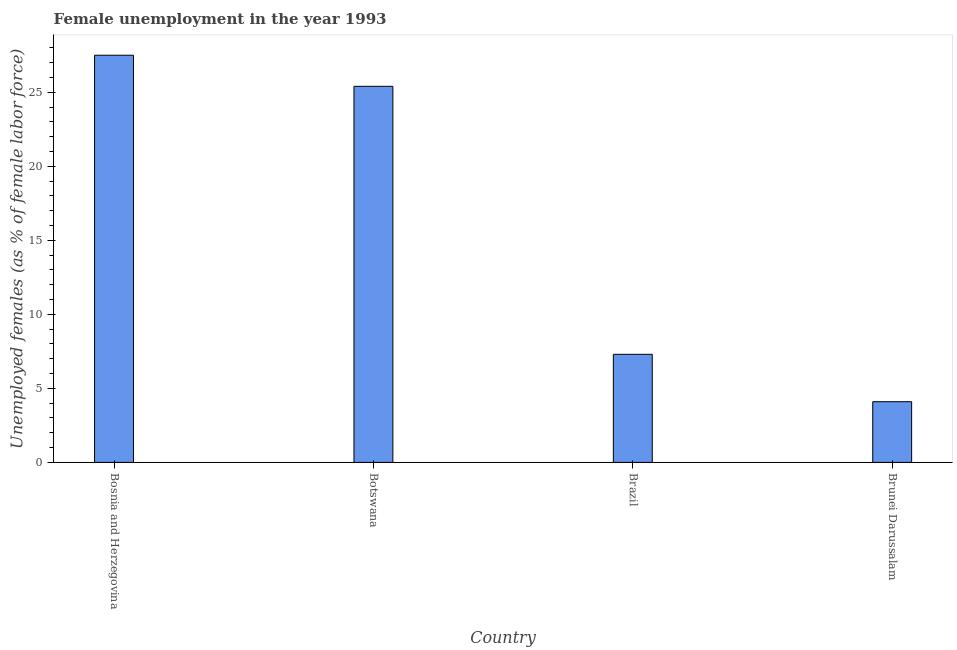Does the graph contain any zero values?
Ensure brevity in your answer.  No. Does the graph contain grids?
Your answer should be compact. No. What is the title of the graph?
Provide a short and direct response. Female unemployment in the year 1993. What is the label or title of the X-axis?
Your answer should be compact. Country. What is the label or title of the Y-axis?
Keep it short and to the point. Unemployed females (as % of female labor force). What is the unemployed females population in Botswana?
Make the answer very short. 25.4. Across all countries, what is the minimum unemployed females population?
Keep it short and to the point. 4.1. In which country was the unemployed females population maximum?
Provide a short and direct response. Bosnia and Herzegovina. In which country was the unemployed females population minimum?
Offer a terse response. Brunei Darussalam. What is the sum of the unemployed females population?
Provide a succinct answer. 64.3. What is the difference between the unemployed females population in Brazil and Brunei Darussalam?
Keep it short and to the point. 3.2. What is the average unemployed females population per country?
Offer a terse response. 16.07. What is the median unemployed females population?
Offer a terse response. 16.35. In how many countries, is the unemployed females population greater than 12 %?
Ensure brevity in your answer.  2. What is the ratio of the unemployed females population in Bosnia and Herzegovina to that in Brazil?
Offer a terse response. 3.77. Is the difference between the unemployed females population in Botswana and Brazil greater than the difference between any two countries?
Give a very brief answer. No. What is the difference between the highest and the lowest unemployed females population?
Ensure brevity in your answer.  23.4. In how many countries, is the unemployed females population greater than the average unemployed females population taken over all countries?
Provide a succinct answer. 2. How many bars are there?
Ensure brevity in your answer.  4. Are all the bars in the graph horizontal?
Offer a very short reply. No. How many countries are there in the graph?
Keep it short and to the point. 4. What is the difference between two consecutive major ticks on the Y-axis?
Your answer should be very brief. 5. Are the values on the major ticks of Y-axis written in scientific E-notation?
Give a very brief answer. No. What is the Unemployed females (as % of female labor force) in Botswana?
Give a very brief answer. 25.4. What is the Unemployed females (as % of female labor force) of Brazil?
Give a very brief answer. 7.3. What is the Unemployed females (as % of female labor force) in Brunei Darussalam?
Ensure brevity in your answer.  4.1. What is the difference between the Unemployed females (as % of female labor force) in Bosnia and Herzegovina and Brazil?
Make the answer very short. 20.2. What is the difference between the Unemployed females (as % of female labor force) in Bosnia and Herzegovina and Brunei Darussalam?
Provide a short and direct response. 23.4. What is the difference between the Unemployed females (as % of female labor force) in Botswana and Brazil?
Your response must be concise. 18.1. What is the difference between the Unemployed females (as % of female labor force) in Botswana and Brunei Darussalam?
Your answer should be very brief. 21.3. What is the difference between the Unemployed females (as % of female labor force) in Brazil and Brunei Darussalam?
Make the answer very short. 3.2. What is the ratio of the Unemployed females (as % of female labor force) in Bosnia and Herzegovina to that in Botswana?
Your answer should be very brief. 1.08. What is the ratio of the Unemployed females (as % of female labor force) in Bosnia and Herzegovina to that in Brazil?
Provide a short and direct response. 3.77. What is the ratio of the Unemployed females (as % of female labor force) in Bosnia and Herzegovina to that in Brunei Darussalam?
Your response must be concise. 6.71. What is the ratio of the Unemployed females (as % of female labor force) in Botswana to that in Brazil?
Provide a short and direct response. 3.48. What is the ratio of the Unemployed females (as % of female labor force) in Botswana to that in Brunei Darussalam?
Offer a very short reply. 6.2. What is the ratio of the Unemployed females (as % of female labor force) in Brazil to that in Brunei Darussalam?
Make the answer very short. 1.78. 